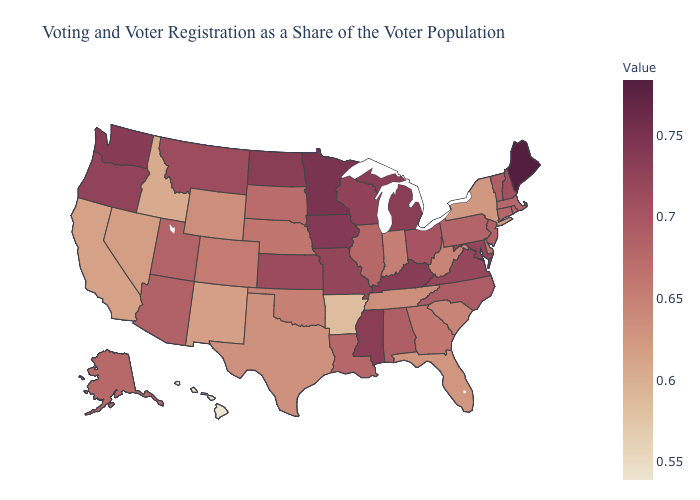Which states have the lowest value in the South?
Write a very short answer. Arkansas. Does West Virginia have a lower value than Ohio?
Be succinct. Yes. Does Maine have the highest value in the Northeast?
Keep it brief. Yes. Among the states that border Missouri , does Tennessee have the lowest value?
Be succinct. No. Does Arizona have a lower value than Indiana?
Concise answer only. No. Which states have the highest value in the USA?
Give a very brief answer. Maine. Among the states that border Oklahoma , does Missouri have the highest value?
Answer briefly. Yes. 